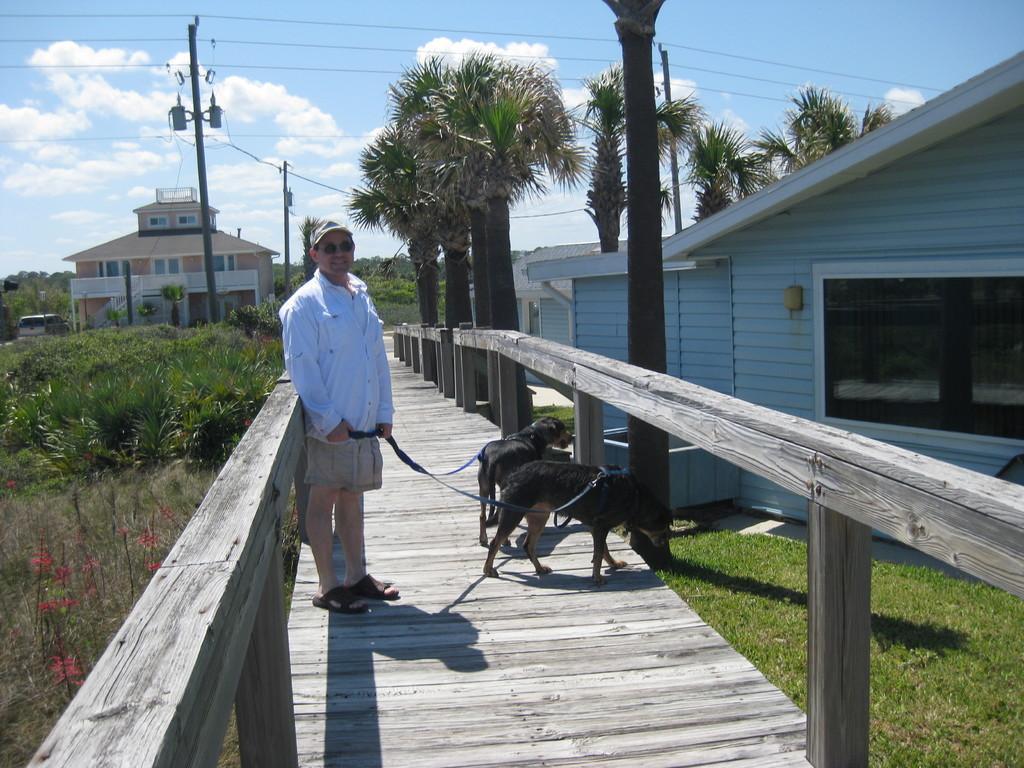Can you describe this image briefly? In this image there is a person with glasses holding the dog belts and standing on the wooden path. Image also consists of trees, plants and grass. We can also see some buildings and poles with wires. At the top there is sky with some clouds. 